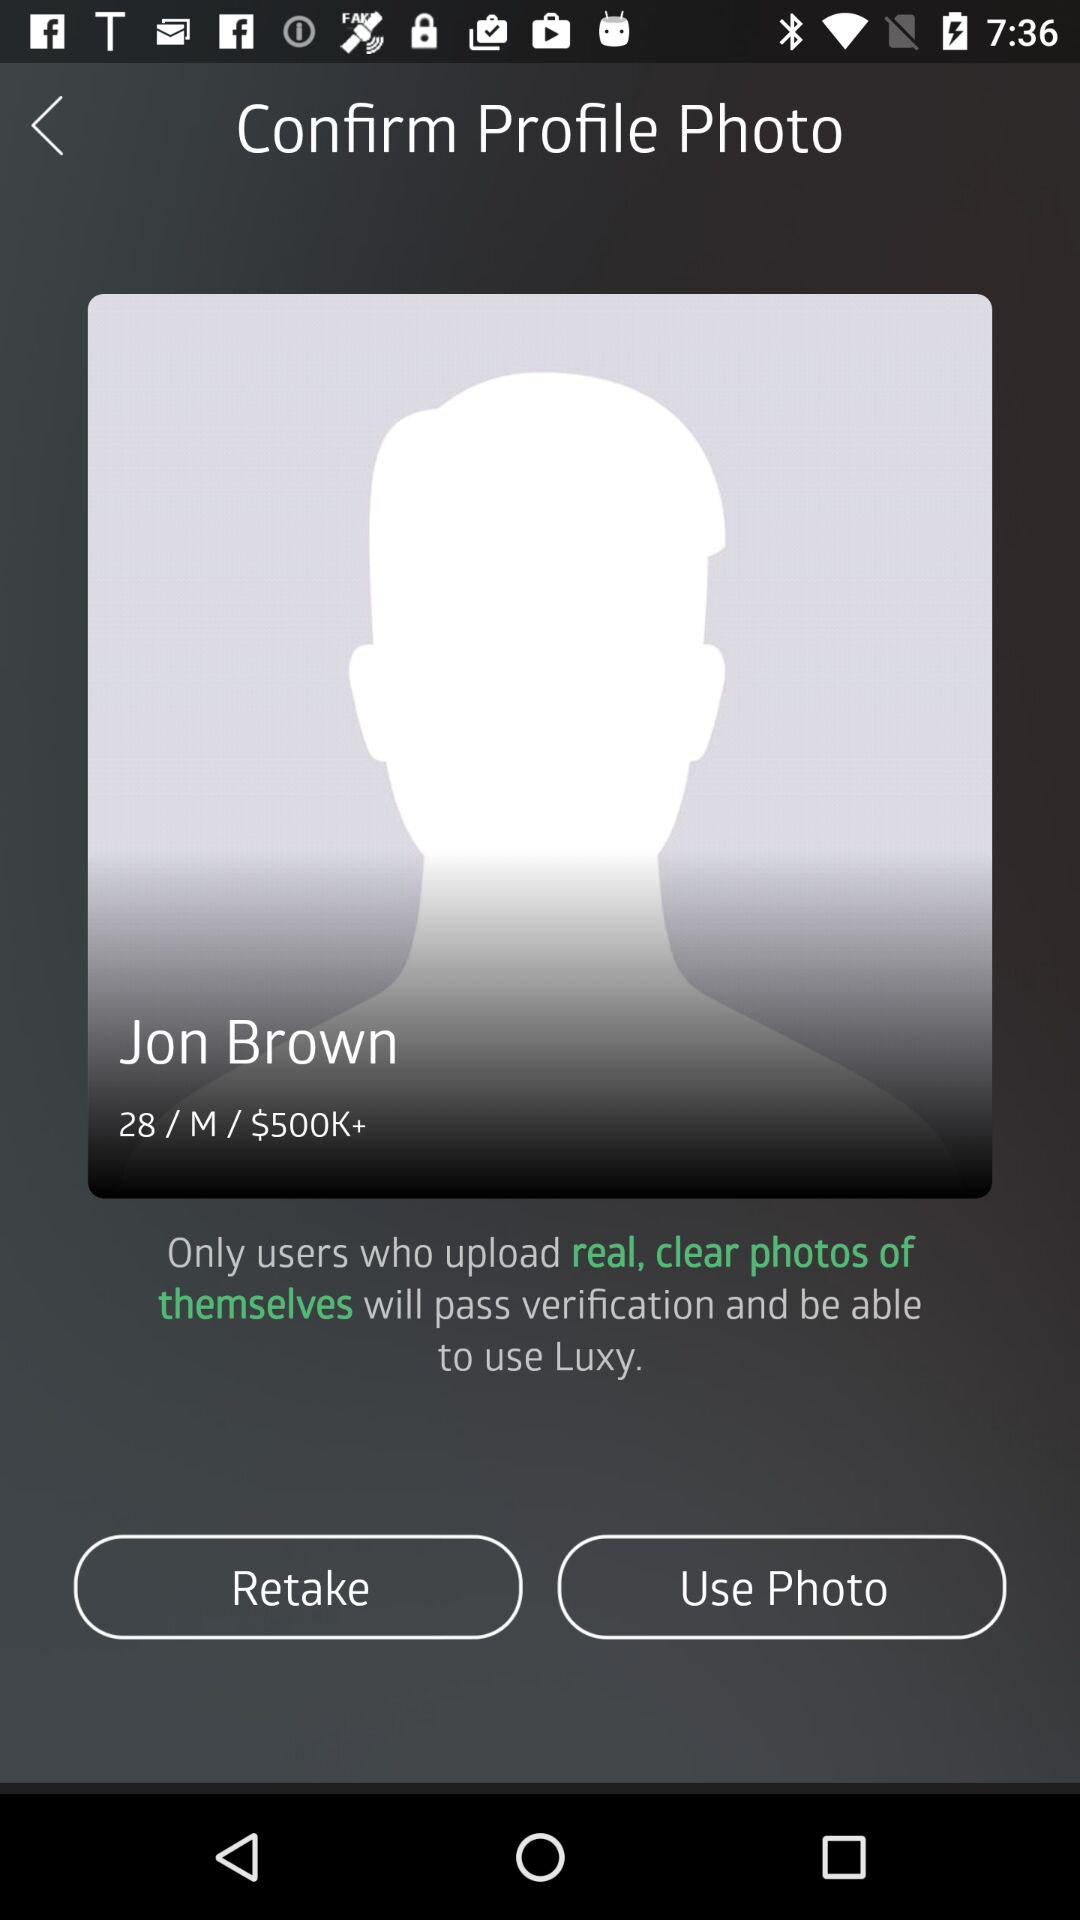What is the gender of Jon Brown? The gender of Jon Brown is male. 